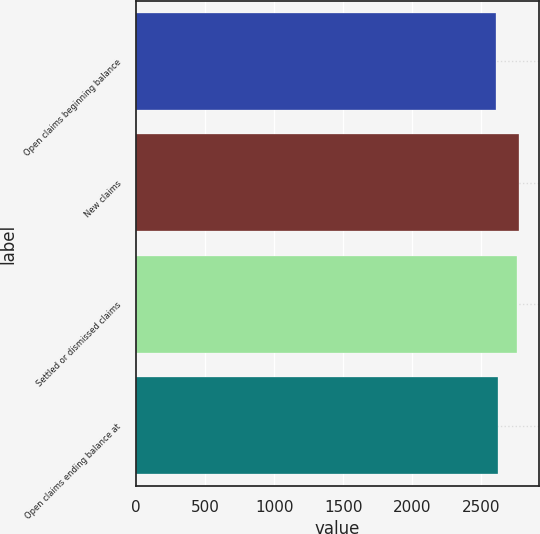Convert chart. <chart><loc_0><loc_0><loc_500><loc_500><bar_chart><fcel>Open claims beginning balance<fcel>New claims<fcel>Settled or dismissed claims<fcel>Open claims ending balance at<nl><fcel>2605<fcel>2776.8<fcel>2760<fcel>2621.8<nl></chart> 